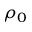Convert formula to latex. <formula><loc_0><loc_0><loc_500><loc_500>\rho _ { 0 }</formula> 